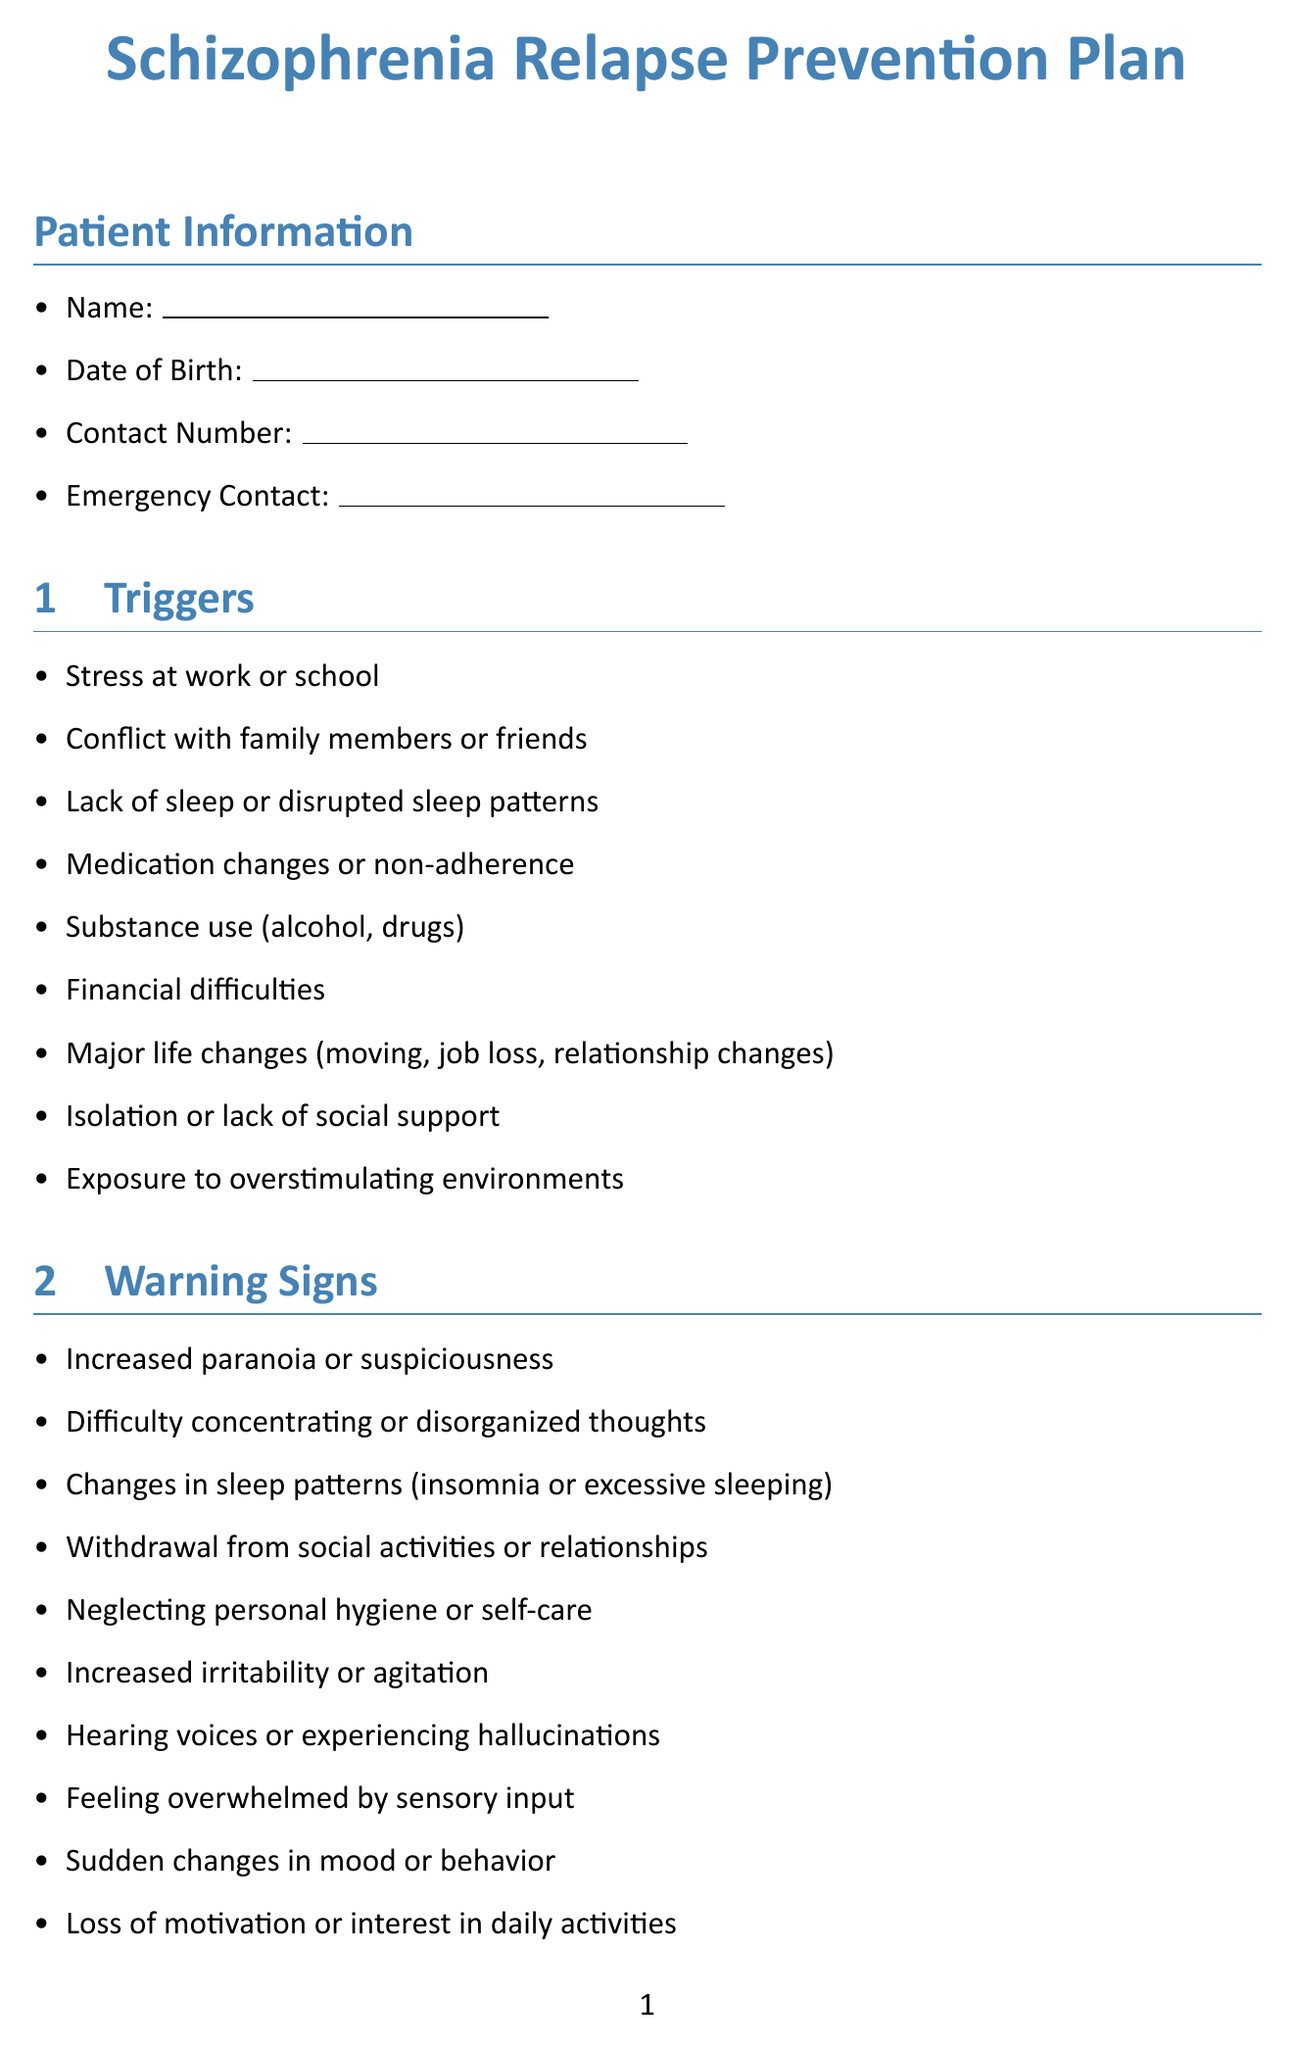What is the title of the document? The title of the document is stated at the top and presents the main focus of the content.
Answer: Schizophrenia Relapse Prevention Plan What is one of the triggers listed? The triggers section provides a list of factors that may lead to relapse; any of these listed items can be a valid answer.
Answer: Stress at work or school What is the name of the psychiatrist in the support network? This information is presented in the mental health professionals section of the document.
Answer: Dr. Sarah Johnson How many coping strategies are provided? The coping strategies section contains a list that determines the count of strategies offered for management.
Answer: 10 What should a person do if they experience hearing voices? This is inferred from the steps outlined in the crisis management plan, suggesting specific actions to take during a crisis.
Answer: Contact emergency support person What is one side effect to monitor for medications? One of the side effects is directly listed under the medication management section for monitoring.
Answer: Weight gain What is the local crisis hotline? This indicates a specific piece of emergency contact information that is included for immediate assistance when required.
Answer: [left blank for entry] What is a short-term goal left blank for the patient to fill in? This question addresses the goals and aspirations section where personal goals are to be recorded.
Answer: [left blank for entry] What kind of routine is mentioned in the document? The document includes a section dedicated to this aspect of daily management for better mental health.
Answer: Daily Wellness Routine 